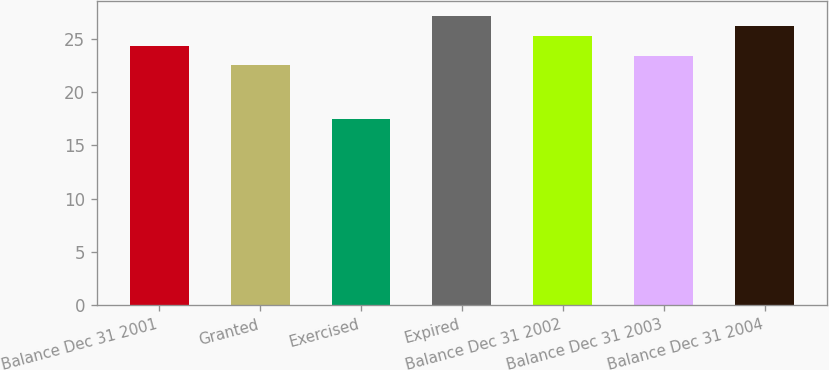Convert chart. <chart><loc_0><loc_0><loc_500><loc_500><bar_chart><fcel>Balance Dec 31 2001<fcel>Granted<fcel>Exercised<fcel>Expired<fcel>Balance Dec 31 2002<fcel>Balance Dec 31 2003<fcel>Balance Dec 31 2004<nl><fcel>24.34<fcel>22.49<fcel>17.48<fcel>27.12<fcel>25.27<fcel>23.41<fcel>26.2<nl></chart> 